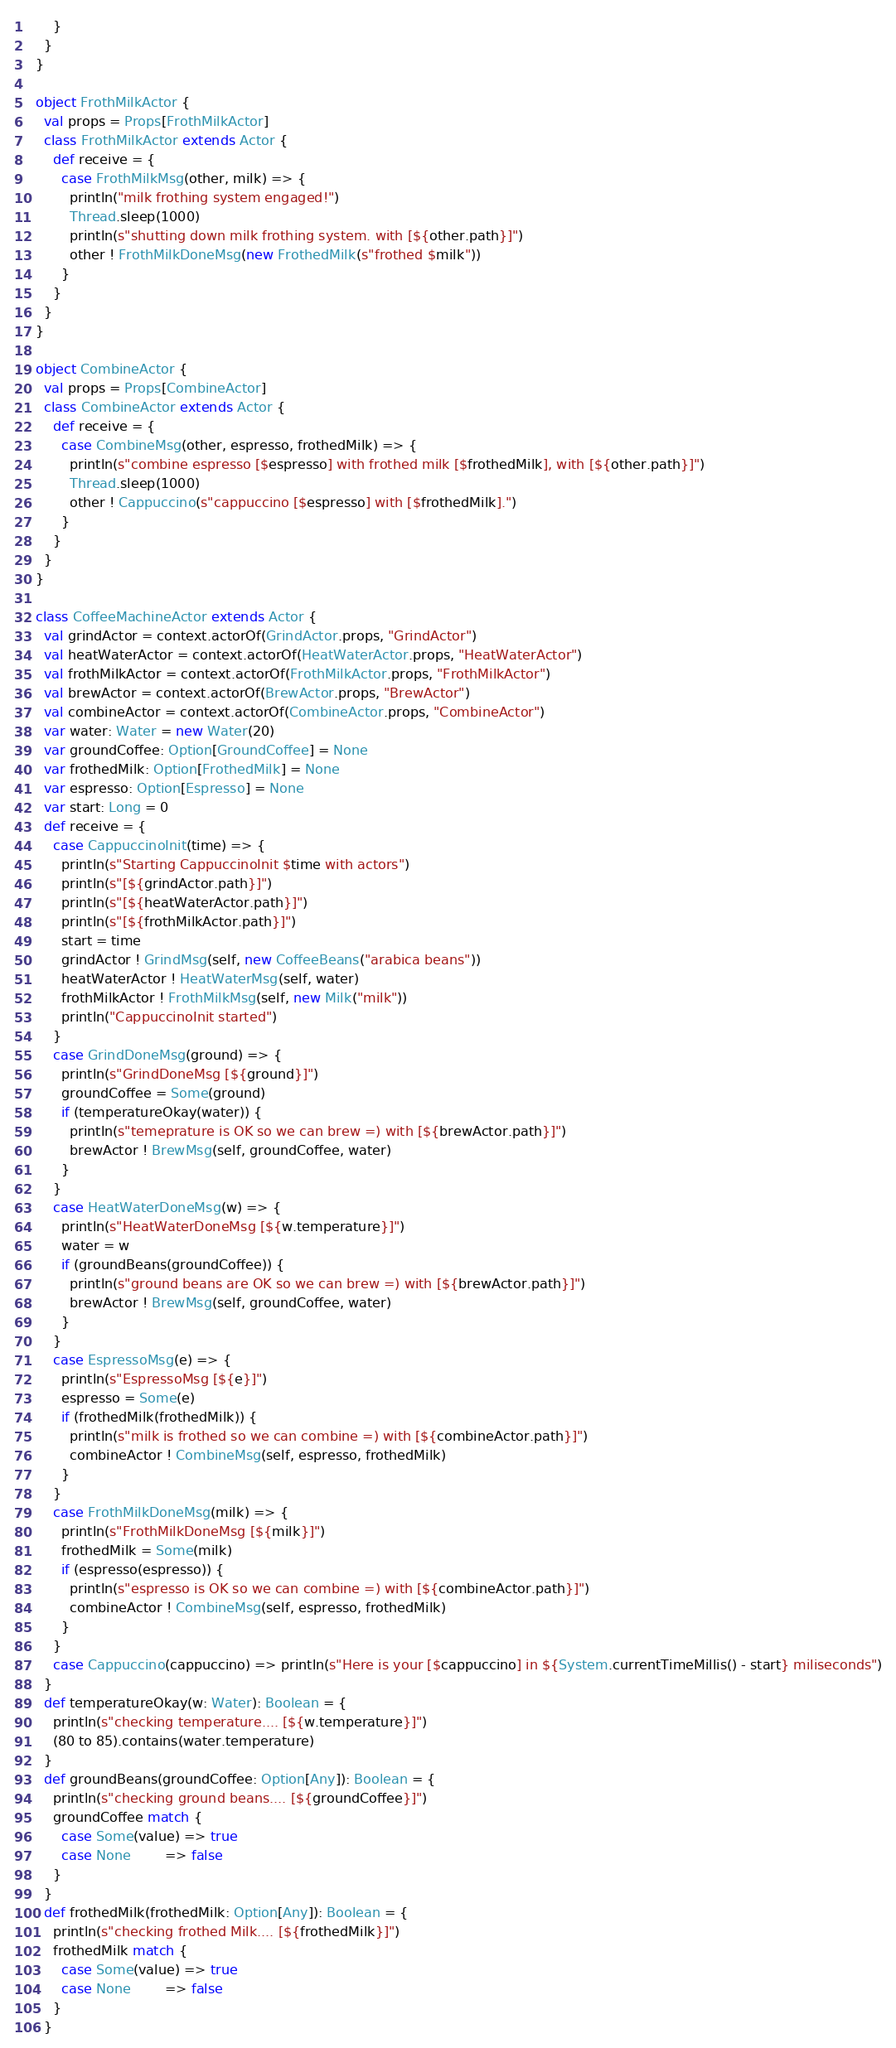Convert code to text. <code><loc_0><loc_0><loc_500><loc_500><_Scala_>      }
    }
  }

  object FrothMilkActor {
    val props = Props[FrothMilkActor]
    class FrothMilkActor extends Actor {
      def receive = {
        case FrothMilkMsg(other, milk) => {
          println("milk frothing system engaged!")
          Thread.sleep(1000)
          println(s"shutting down milk frothing system. with [${other.path}]")
          other ! FrothMilkDoneMsg(new FrothedMilk(s"frothed $milk"))
        }
      }
    }
  }

  object CombineActor {
    val props = Props[CombineActor]
    class CombineActor extends Actor {
      def receive = {
        case CombineMsg(other, espresso, frothedMilk) => {
          println(s"combine espresso [$espresso] with frothed milk [$frothedMilk], with [${other.path}]")
          Thread.sleep(1000)
          other ! Cappuccino(s"cappuccino [$espresso] with [$frothedMilk].")
        }
      }
    }
  }

  class CoffeeMachineActor extends Actor {
    val grindActor = context.actorOf(GrindActor.props, "GrindActor")
    val heatWaterActor = context.actorOf(HeatWaterActor.props, "HeatWaterActor")
    val frothMilkActor = context.actorOf(FrothMilkActor.props, "FrothMilkActor")
    val brewActor = context.actorOf(BrewActor.props, "BrewActor")
    val combineActor = context.actorOf(CombineActor.props, "CombineActor")
    var water: Water = new Water(20)
    var groundCoffee: Option[GroundCoffee] = None
    var frothedMilk: Option[FrothedMilk] = None
    var espresso: Option[Espresso] = None
    var start: Long = 0
    def receive = {
      case CappuccinoInit(time) => {
        println(s"Starting CappuccinoInit $time with actors")
        println(s"[${grindActor.path}]")
        println(s"[${heatWaterActor.path}]")
        println(s"[${frothMilkActor.path}]")
        start = time
        grindActor ! GrindMsg(self, new CoffeeBeans("arabica beans"))
        heatWaterActor ! HeatWaterMsg(self, water)
        frothMilkActor ! FrothMilkMsg(self, new Milk("milk"))
        println("CappuccinoInit started")
      }
      case GrindDoneMsg(ground) => {
        println(s"GrindDoneMsg [${ground}]")
        groundCoffee = Some(ground)
        if (temperatureOkay(water)) {
          println(s"temeprature is OK so we can brew =) with [${brewActor.path}]")
          brewActor ! BrewMsg(self, groundCoffee, water)
        }
      }
      case HeatWaterDoneMsg(w) => {
        println(s"HeatWaterDoneMsg [${w.temperature}]")
        water = w
        if (groundBeans(groundCoffee)) {
          println(s"ground beans are OK so we can brew =) with [${brewActor.path}]")
          brewActor ! BrewMsg(self, groundCoffee, water)
        }
      }
      case EspressoMsg(e) => {
        println(s"EspressoMsg [${e}]")
        espresso = Some(e)
        if (frothedMilk(frothedMilk)) {
          println(s"milk is frothed so we can combine =) with [${combineActor.path}]")
          combineActor ! CombineMsg(self, espresso, frothedMilk)
        }
      }
      case FrothMilkDoneMsg(milk) => {
        println(s"FrothMilkDoneMsg [${milk}]")
        frothedMilk = Some(milk)
        if (espresso(espresso)) {
          println(s"espresso is OK so we can combine =) with [${combineActor.path}]")
          combineActor ! CombineMsg(self, espresso, frothedMilk)
        }
      }
      case Cappuccino(cappuccino) => println(s"Here is your [$cappuccino] in ${System.currentTimeMillis() - start} miliseconds")
    }
    def temperatureOkay(w: Water): Boolean = {
      println(s"checking temperature.... [${w.temperature}]")
      (80 to 85).contains(water.temperature)
    }
    def groundBeans(groundCoffee: Option[Any]): Boolean = {
      println(s"checking ground beans.... [${groundCoffee}]")
      groundCoffee match {
        case Some(value) => true
        case None        => false
      }
    }
    def frothedMilk(frothedMilk: Option[Any]): Boolean = {
      println(s"checking frothed Milk.... [${frothedMilk}]")
      frothedMilk match {
        case Some(value) => true
        case None        => false
      }
    }</code> 